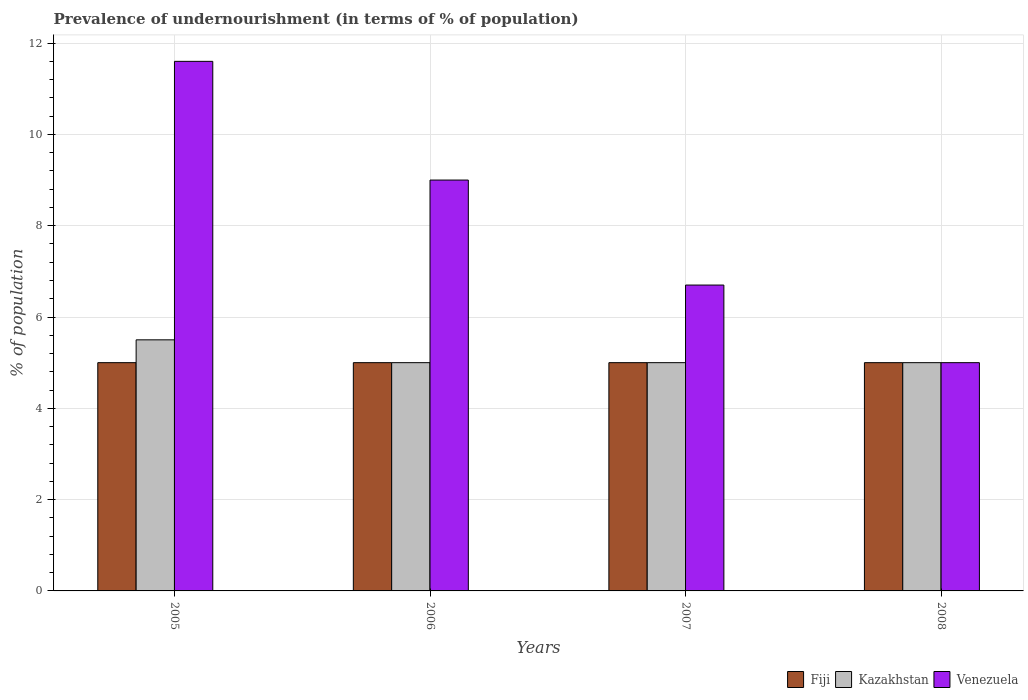Are the number of bars on each tick of the X-axis equal?
Your response must be concise. Yes. How many bars are there on the 3rd tick from the right?
Ensure brevity in your answer.  3. In which year was the percentage of undernourished population in Fiji maximum?
Offer a terse response. 2005. In which year was the percentage of undernourished population in Venezuela minimum?
Ensure brevity in your answer.  2008. What is the total percentage of undernourished population in Kazakhstan in the graph?
Offer a very short reply. 20.5. What is the difference between the percentage of undernourished population in Kazakhstan in 2006 and that in 2007?
Provide a short and direct response. 0. What is the average percentage of undernourished population in Venezuela per year?
Your answer should be compact. 8.07. In the year 2006, what is the difference between the percentage of undernourished population in Venezuela and percentage of undernourished population in Fiji?
Your answer should be very brief. 4. What is the difference between the highest and the second highest percentage of undernourished population in Venezuela?
Provide a short and direct response. 2.6. What does the 3rd bar from the left in 2008 represents?
Your answer should be compact. Venezuela. What does the 3rd bar from the right in 2006 represents?
Provide a succinct answer. Fiji. Is it the case that in every year, the sum of the percentage of undernourished population in Fiji and percentage of undernourished population in Venezuela is greater than the percentage of undernourished population in Kazakhstan?
Make the answer very short. Yes. How many bars are there?
Offer a terse response. 12. Does the graph contain any zero values?
Provide a succinct answer. No. How many legend labels are there?
Provide a succinct answer. 3. How are the legend labels stacked?
Provide a succinct answer. Horizontal. What is the title of the graph?
Make the answer very short. Prevalence of undernourishment (in terms of % of population). Does "Croatia" appear as one of the legend labels in the graph?
Provide a succinct answer. No. What is the label or title of the Y-axis?
Offer a very short reply. % of population. What is the % of population in Fiji in 2005?
Give a very brief answer. 5. What is the % of population in Kazakhstan in 2005?
Give a very brief answer. 5.5. What is the % of population in Venezuela in 2005?
Keep it short and to the point. 11.6. What is the % of population in Kazakhstan in 2006?
Keep it short and to the point. 5. What is the % of population of Venezuela in 2006?
Your response must be concise. 9. What is the % of population in Kazakhstan in 2007?
Provide a short and direct response. 5. What is the % of population in Fiji in 2008?
Give a very brief answer. 5. What is the % of population of Venezuela in 2008?
Your answer should be compact. 5. Across all years, what is the maximum % of population in Fiji?
Provide a short and direct response. 5. Across all years, what is the minimum % of population in Fiji?
Ensure brevity in your answer.  5. Across all years, what is the minimum % of population in Kazakhstan?
Your response must be concise. 5. What is the total % of population in Venezuela in the graph?
Your answer should be compact. 32.3. What is the difference between the % of population in Fiji in 2005 and that in 2006?
Keep it short and to the point. 0. What is the difference between the % of population in Kazakhstan in 2005 and that in 2006?
Your answer should be very brief. 0.5. What is the difference between the % of population of Venezuela in 2005 and that in 2006?
Provide a succinct answer. 2.6. What is the difference between the % of population in Kazakhstan in 2005 and that in 2007?
Provide a short and direct response. 0.5. What is the difference between the % of population in Venezuela in 2005 and that in 2007?
Offer a very short reply. 4.9. What is the difference between the % of population in Venezuela in 2006 and that in 2007?
Offer a terse response. 2.3. What is the difference between the % of population of Fiji in 2007 and that in 2008?
Provide a short and direct response. 0. What is the difference between the % of population in Venezuela in 2007 and that in 2008?
Give a very brief answer. 1.7. What is the difference between the % of population of Fiji in 2005 and the % of population of Venezuela in 2006?
Make the answer very short. -4. What is the difference between the % of population in Kazakhstan in 2005 and the % of population in Venezuela in 2006?
Your response must be concise. -3.5. What is the difference between the % of population of Fiji in 2005 and the % of population of Kazakhstan in 2007?
Keep it short and to the point. 0. What is the difference between the % of population in Fiji in 2005 and the % of population in Venezuela in 2007?
Keep it short and to the point. -1.7. What is the difference between the % of population in Fiji in 2005 and the % of population in Kazakhstan in 2008?
Ensure brevity in your answer.  0. What is the difference between the % of population in Fiji in 2005 and the % of population in Venezuela in 2008?
Your answer should be very brief. 0. What is the difference between the % of population of Fiji in 2006 and the % of population of Kazakhstan in 2007?
Provide a short and direct response. 0. What is the difference between the % of population in Fiji in 2006 and the % of population in Venezuela in 2007?
Provide a succinct answer. -1.7. What is the difference between the % of population of Fiji in 2006 and the % of population of Venezuela in 2008?
Offer a very short reply. 0. What is the difference between the % of population in Fiji in 2007 and the % of population in Venezuela in 2008?
Your answer should be compact. 0. What is the difference between the % of population of Kazakhstan in 2007 and the % of population of Venezuela in 2008?
Make the answer very short. 0. What is the average % of population of Kazakhstan per year?
Your response must be concise. 5.12. What is the average % of population of Venezuela per year?
Your response must be concise. 8.07. In the year 2005, what is the difference between the % of population in Fiji and % of population in Kazakhstan?
Ensure brevity in your answer.  -0.5. In the year 2005, what is the difference between the % of population in Fiji and % of population in Venezuela?
Make the answer very short. -6.6. In the year 2007, what is the difference between the % of population in Fiji and % of population in Kazakhstan?
Your response must be concise. 0. In the year 2007, what is the difference between the % of population of Fiji and % of population of Venezuela?
Make the answer very short. -1.7. In the year 2008, what is the difference between the % of population in Fiji and % of population in Kazakhstan?
Ensure brevity in your answer.  0. In the year 2008, what is the difference between the % of population of Kazakhstan and % of population of Venezuela?
Your response must be concise. 0. What is the ratio of the % of population of Fiji in 2005 to that in 2006?
Your answer should be compact. 1. What is the ratio of the % of population in Venezuela in 2005 to that in 2006?
Give a very brief answer. 1.29. What is the ratio of the % of population of Fiji in 2005 to that in 2007?
Your answer should be very brief. 1. What is the ratio of the % of population of Venezuela in 2005 to that in 2007?
Offer a terse response. 1.73. What is the ratio of the % of population of Venezuela in 2005 to that in 2008?
Provide a short and direct response. 2.32. What is the ratio of the % of population in Kazakhstan in 2006 to that in 2007?
Provide a succinct answer. 1. What is the ratio of the % of population of Venezuela in 2006 to that in 2007?
Provide a succinct answer. 1.34. What is the ratio of the % of population in Kazakhstan in 2007 to that in 2008?
Provide a short and direct response. 1. What is the ratio of the % of population of Venezuela in 2007 to that in 2008?
Your answer should be very brief. 1.34. What is the difference between the highest and the second highest % of population of Venezuela?
Your response must be concise. 2.6. What is the difference between the highest and the lowest % of population in Fiji?
Offer a terse response. 0. What is the difference between the highest and the lowest % of population of Kazakhstan?
Your answer should be very brief. 0.5. 